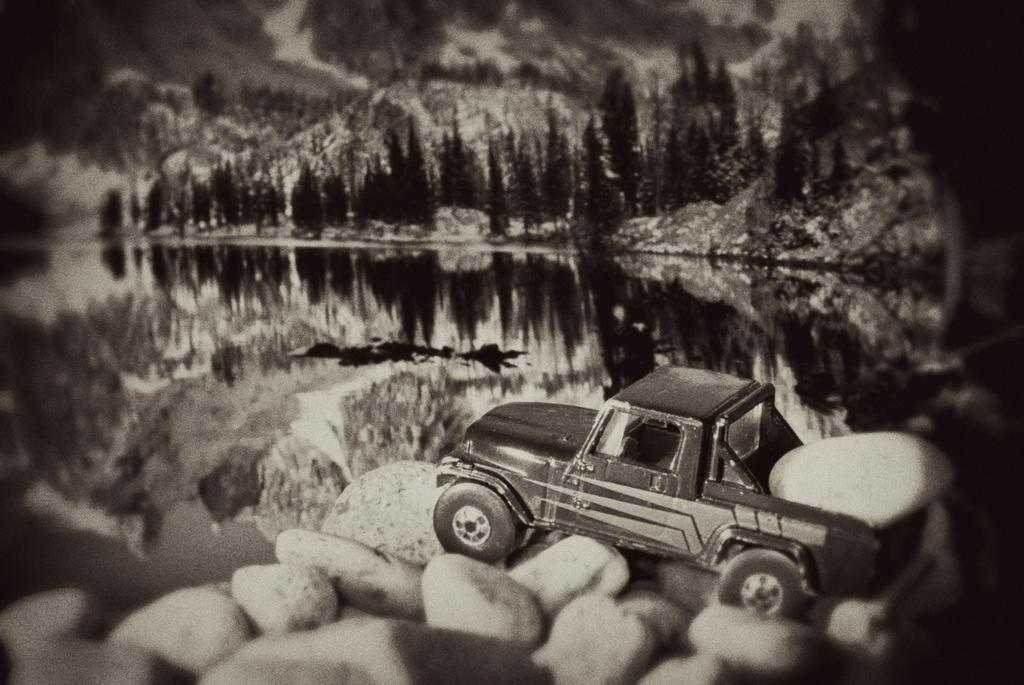What is the main subject in the image? There is a vehicle in the image. What can be seen at the bottom of the image? There are stones at the bottom of the image. What is visible in the background of the image? There is water and trees in the background of the image. What type of landscape feature is visible in the background? There are hills in the background of the image. Where is the pickle located in the image? There is no pickle present in the image. What position is the vehicle in the image? The position of the vehicle cannot be determined from the image alone, as it only shows the vehicle and not its orientation or movement. 